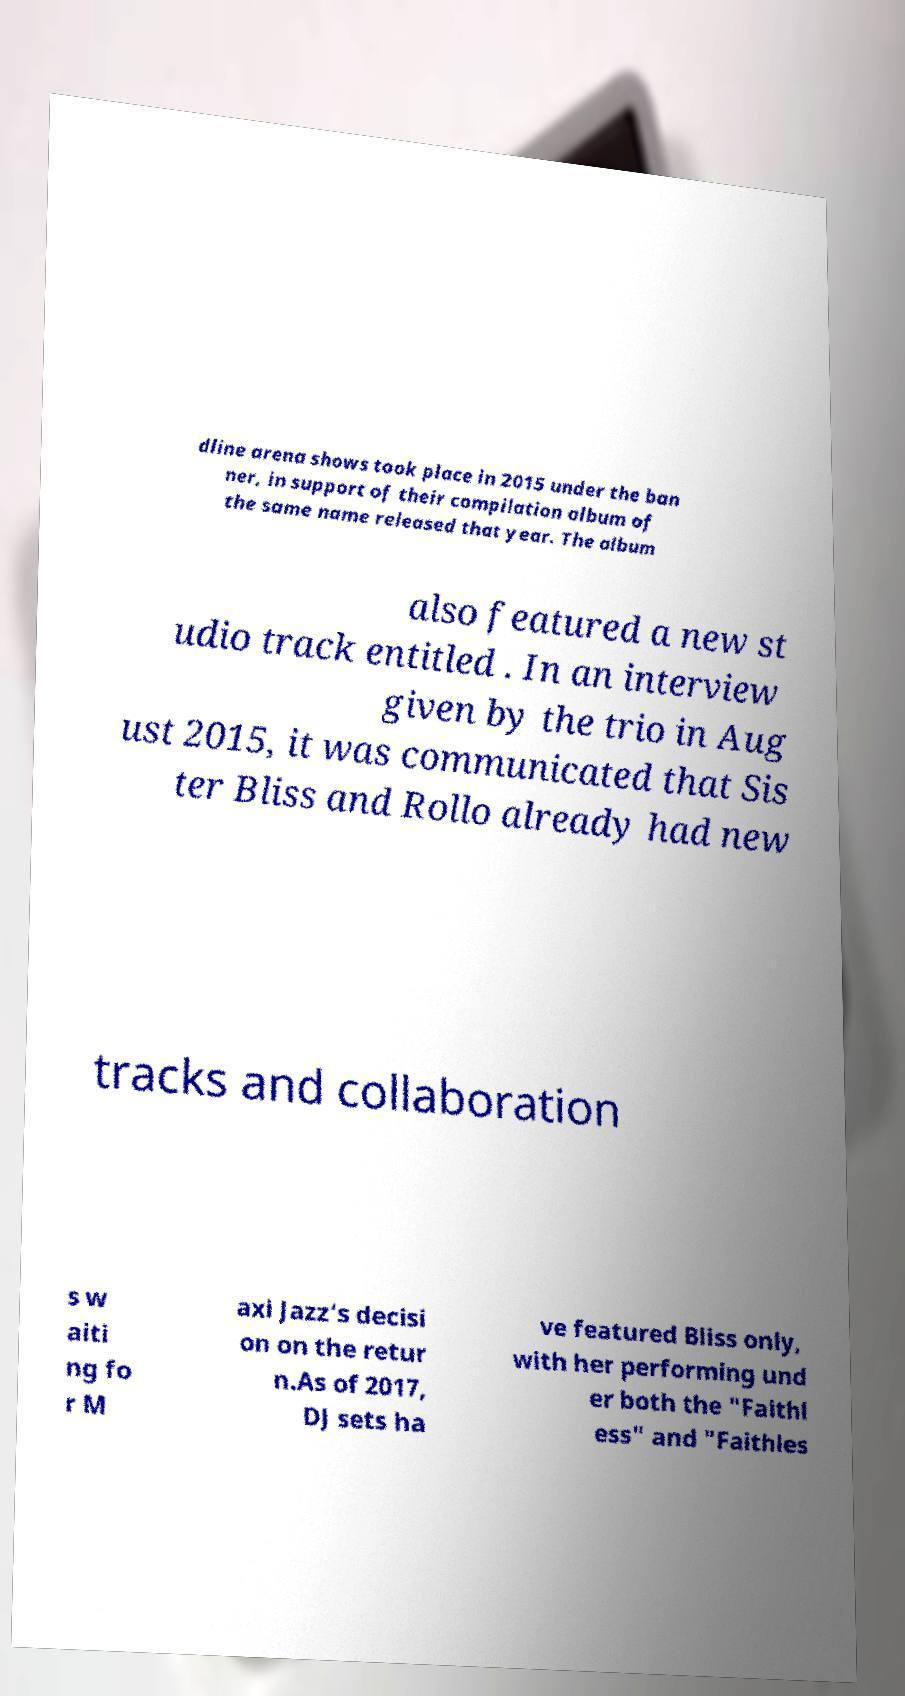Could you assist in decoding the text presented in this image and type it out clearly? dline arena shows took place in 2015 under the ban ner, in support of their compilation album of the same name released that year. The album also featured a new st udio track entitled . In an interview given by the trio in Aug ust 2015, it was communicated that Sis ter Bliss and Rollo already had new tracks and collaboration s w aiti ng fo r M axi Jazz’s decisi on on the retur n.As of 2017, DJ sets ha ve featured Bliss only, with her performing und er both the "Faithl ess" and "Faithles 